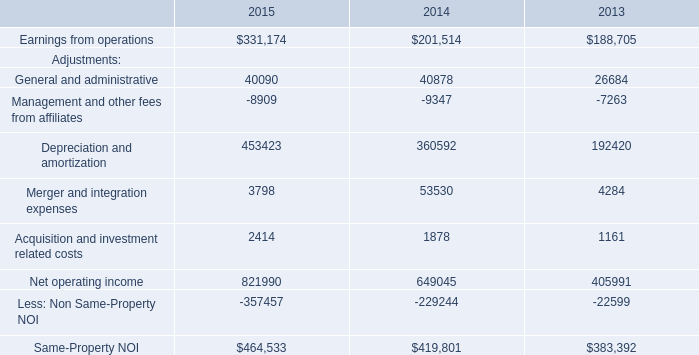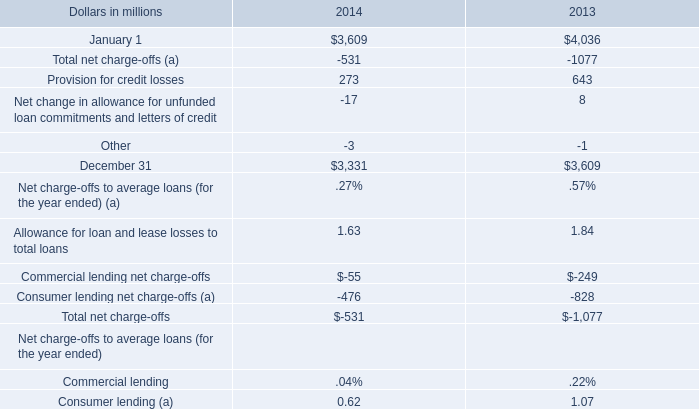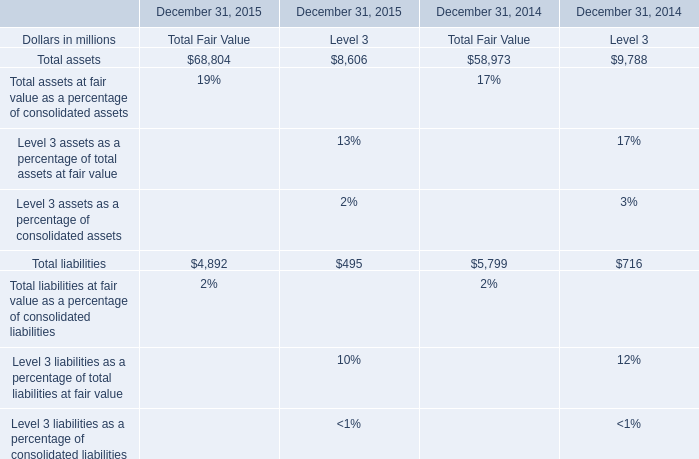what was the ratio of the provision for credit losses in 2014 compared 2013 . 
Computations: (273 / 643)
Answer: 0.42457. 